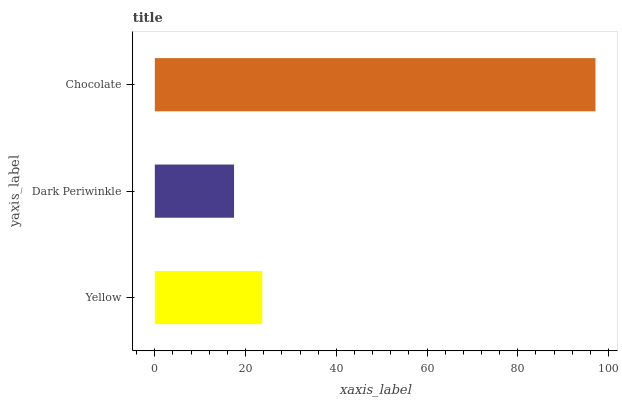Is Dark Periwinkle the minimum?
Answer yes or no. Yes. Is Chocolate the maximum?
Answer yes or no. Yes. Is Chocolate the minimum?
Answer yes or no. No. Is Dark Periwinkle the maximum?
Answer yes or no. No. Is Chocolate greater than Dark Periwinkle?
Answer yes or no. Yes. Is Dark Periwinkle less than Chocolate?
Answer yes or no. Yes. Is Dark Periwinkle greater than Chocolate?
Answer yes or no. No. Is Chocolate less than Dark Periwinkle?
Answer yes or no. No. Is Yellow the high median?
Answer yes or no. Yes. Is Yellow the low median?
Answer yes or no. Yes. Is Dark Periwinkle the high median?
Answer yes or no. No. Is Dark Periwinkle the low median?
Answer yes or no. No. 